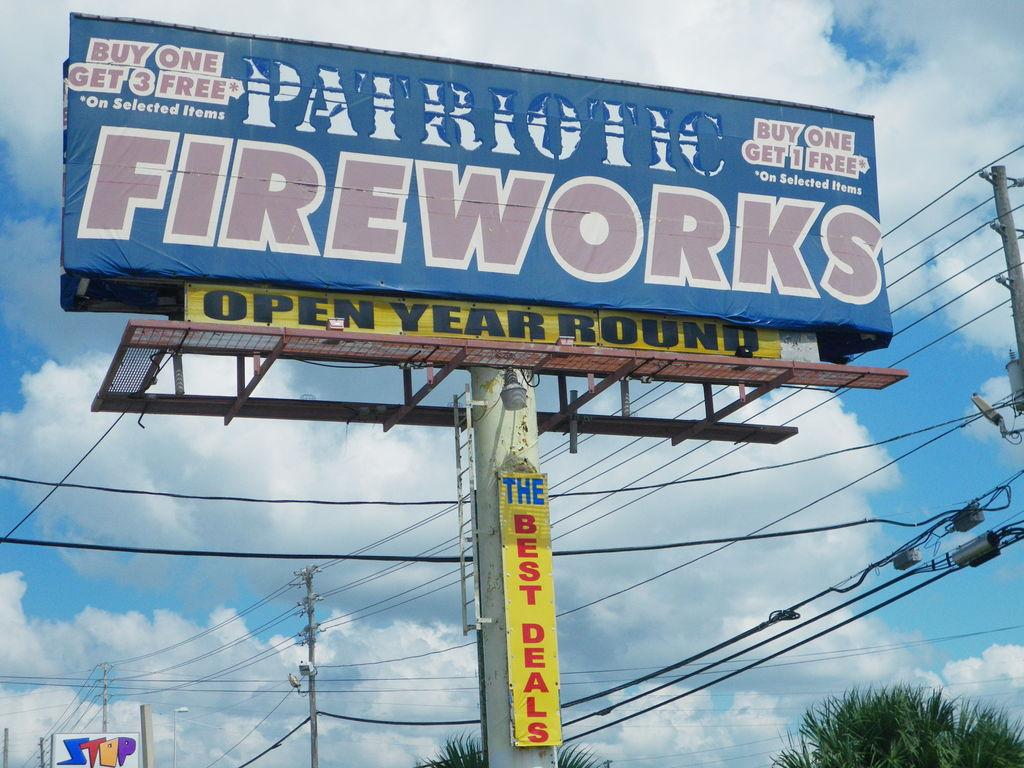What is the name of this fireworks company?
Ensure brevity in your answer.  Patriotic. 